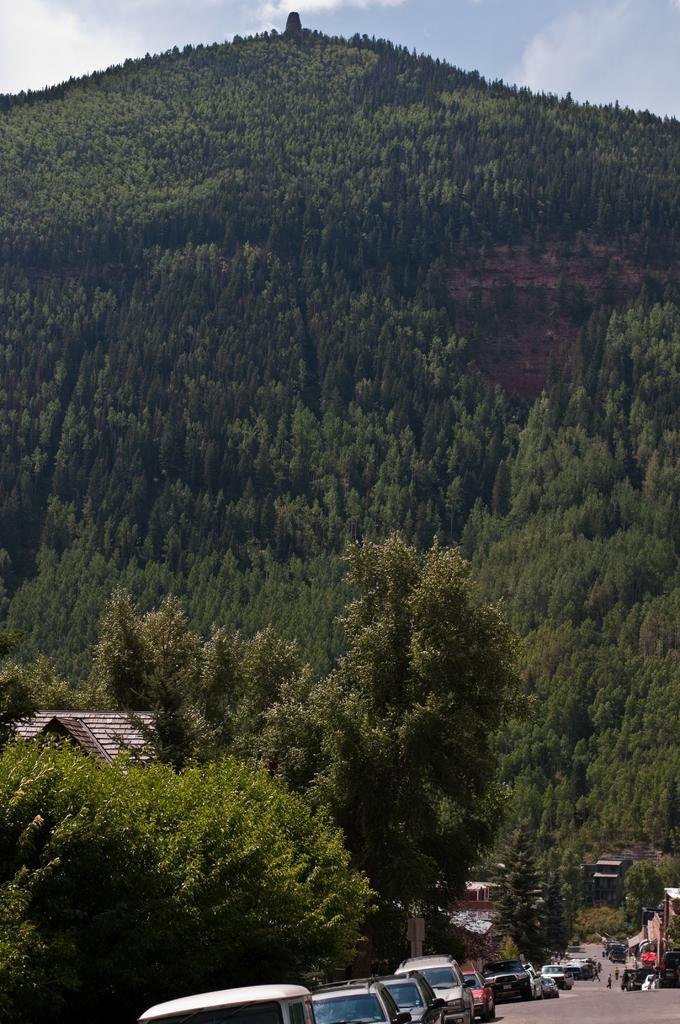Please provide a concise description of this image. This is an outside view. At the bottom there are many cars on the road. In the background there are many trees. On the left side, I can see the roof of a house. At the top of the image, I can see the sky and clouds. 